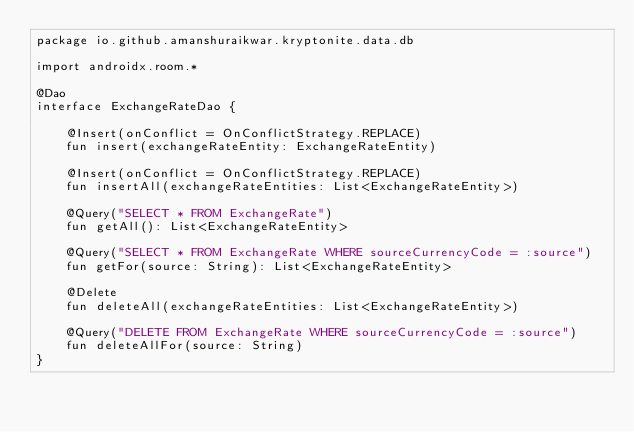Convert code to text. <code><loc_0><loc_0><loc_500><loc_500><_Kotlin_>package io.github.amanshuraikwar.kryptonite.data.db

import androidx.room.*

@Dao
interface ExchangeRateDao {

    @Insert(onConflict = OnConflictStrategy.REPLACE)
    fun insert(exchangeRateEntity: ExchangeRateEntity)

    @Insert(onConflict = OnConflictStrategy.REPLACE)
    fun insertAll(exchangeRateEntities: List<ExchangeRateEntity>)

    @Query("SELECT * FROM ExchangeRate")
    fun getAll(): List<ExchangeRateEntity>

    @Query("SELECT * FROM ExchangeRate WHERE sourceCurrencyCode = :source")
    fun getFor(source: String): List<ExchangeRateEntity>

    @Delete
    fun deleteAll(exchangeRateEntities: List<ExchangeRateEntity>)

    @Query("DELETE FROM ExchangeRate WHERE sourceCurrencyCode = :source")
    fun deleteAllFor(source: String)
}</code> 